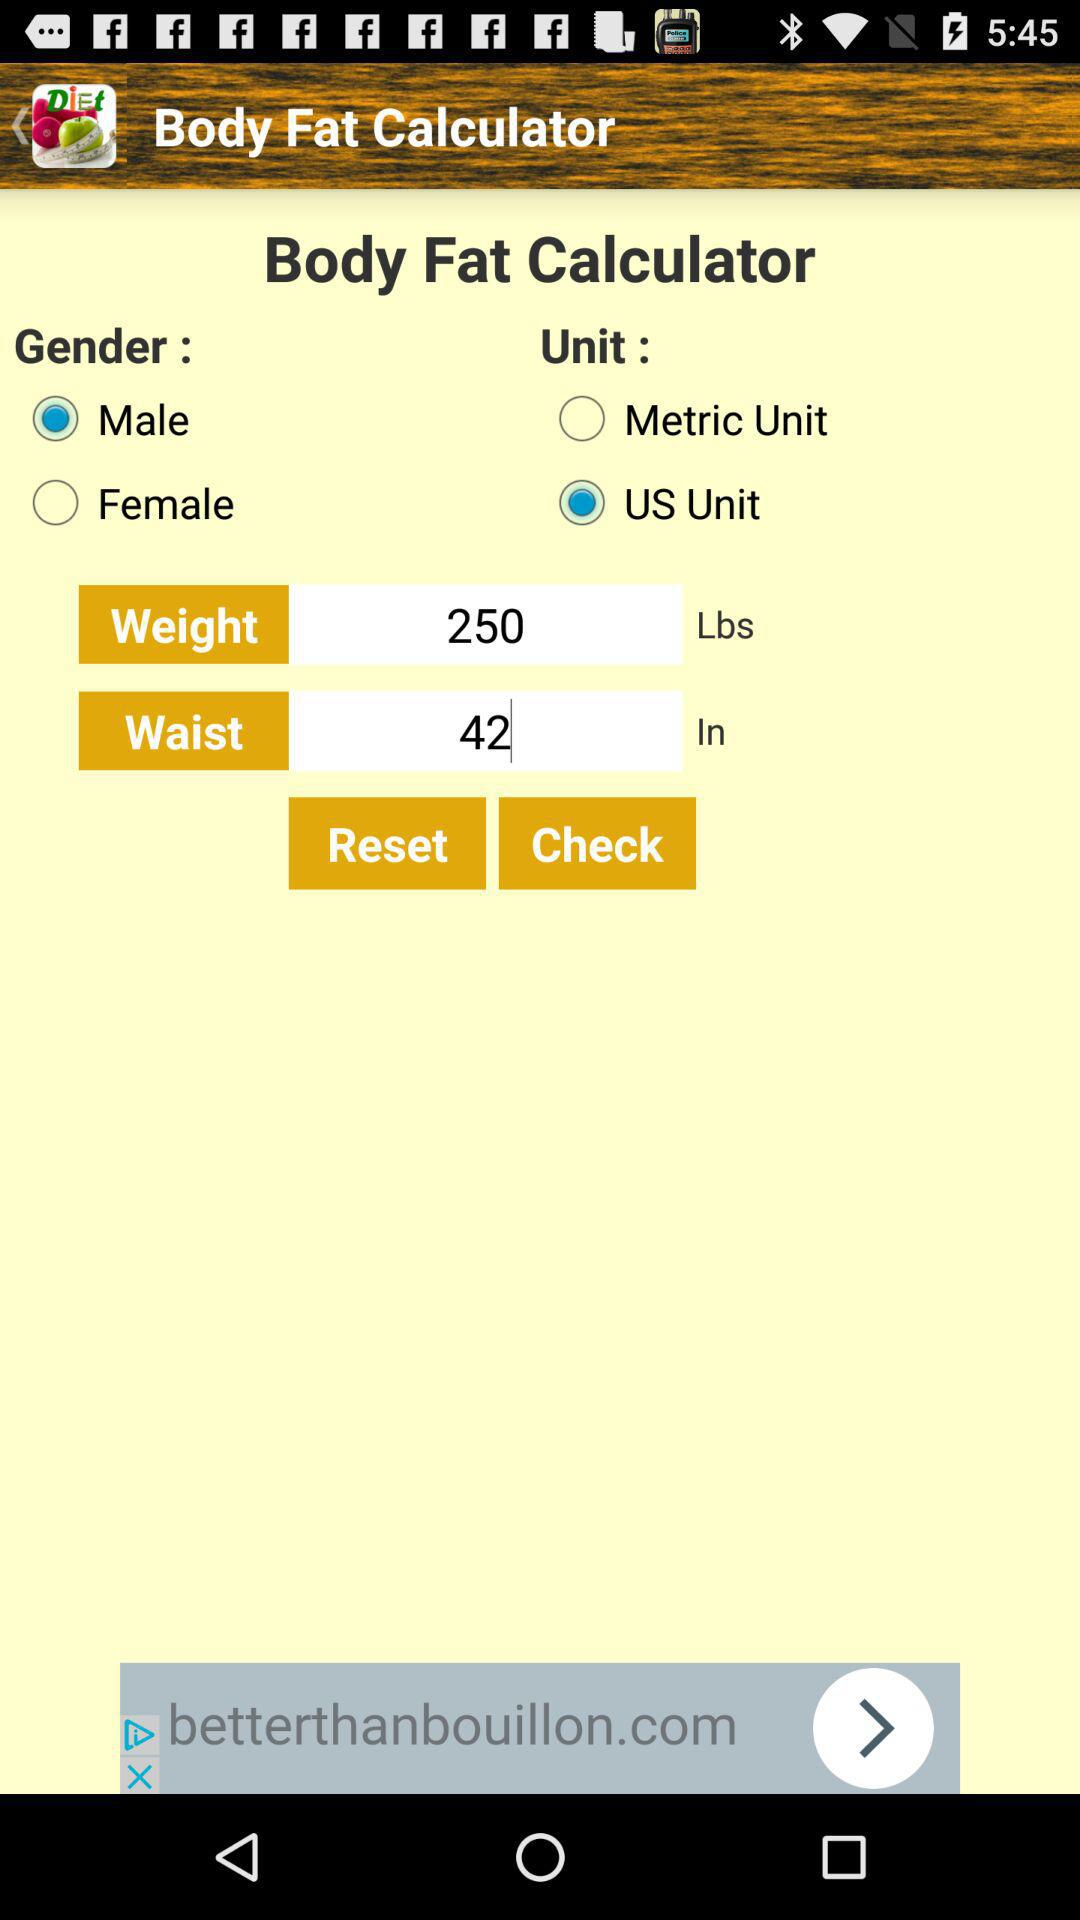How many units are available to choose from?
Answer the question using a single word or phrase. 2 